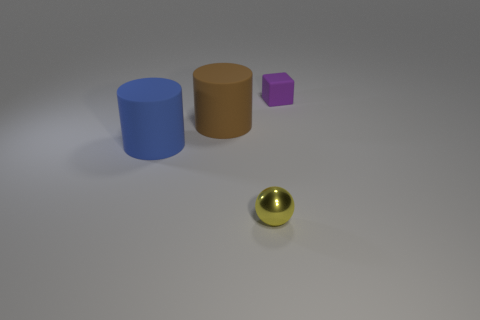What number of purple blocks are there?
Offer a terse response. 1. The tiny thing in front of the big rubber cylinder in front of the large thing that is behind the blue cylinder is made of what material?
Your answer should be very brief. Metal. Are there any cylinders that have the same material as the small purple object?
Make the answer very short. Yes. Does the cube have the same material as the sphere?
Your answer should be compact. No. How many spheres are yellow matte objects or yellow objects?
Your response must be concise. 1. The big object that is the same material as the blue cylinder is what color?
Your response must be concise. Brown. Are there fewer tiny cubes than things?
Ensure brevity in your answer.  Yes. There is a matte thing that is behind the large brown cylinder; does it have the same shape as the small thing in front of the brown thing?
Ensure brevity in your answer.  No. What number of things are either yellow shiny balls or purple things?
Your answer should be compact. 2. What color is the block that is the same size as the yellow object?
Keep it short and to the point. Purple. 